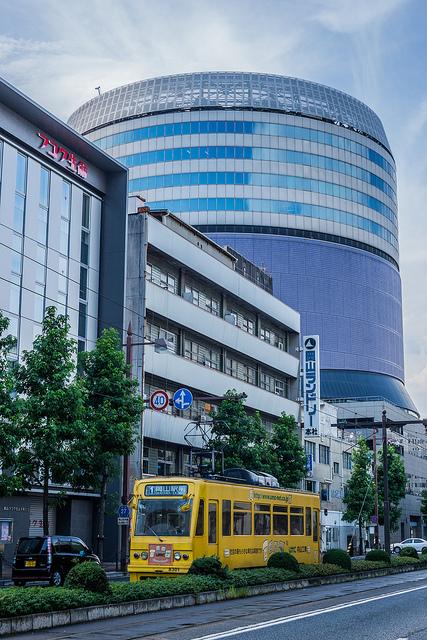Is the sky overcast?
Concise answer only. No. What color is the bus?
Concise answer only. Yellow. Is it daytime?
Short answer required. Yes. Is the bus making a u-turn?
Give a very brief answer. No. 